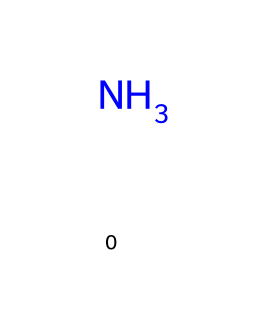What is the chemical name of the substance represented by this structure? The structure contains one nitrogen atom (N), which is characteristic of ammonia. The chemical name for this substance is derived from its molecular composition—specifically, it is ammonia (NH3) when considering its typical bonding with hydrogen.
Answer: ammonia How many atoms are present in this chemical structure? The SMILES representation shows one nitrogen atom but does not display hydrogen atoms explicitly. In the ammonia molecule, there are three hydrogen atoms bonded to one nitrogen atom, resulting in a total of four atoms (1 nitrogen + 3 hydrogens).
Answer: 4 What type of bonding is primarily present in ammonia? Ammonia has covalent bonding as it involves the sharing of electrons between the nitrogen atom and the three hydrogen atoms. This type of bonding is typical for molecular compounds.
Answer: covalent Is ammonia acidic, basic, or neutral? Ammonia is classified as a base, as it can accept protons (H+) due to the lone pair of electrons on the nitrogen atom. This property enables it to participate in acid-base reactions.
Answer: basic What environmental concern is associated with ammonia usage in fertilizers? One significant environmental concern is nutrient runoff, where excess ammonia from fertilizers leaches into waterways, leading to algal blooms and eutrophication, which can severely impact aquatic ecosystems.
Answer: nutrient runoff How does ammonia interact with water to affect its properties? When ammonia dissolves in water, it reacts to form ammonium ions (NH4+) and hydroxide ions (OH-), which increases the pH of the solution. This interaction characterizes ammonia’s behavior as a base.
Answer: increases pH 